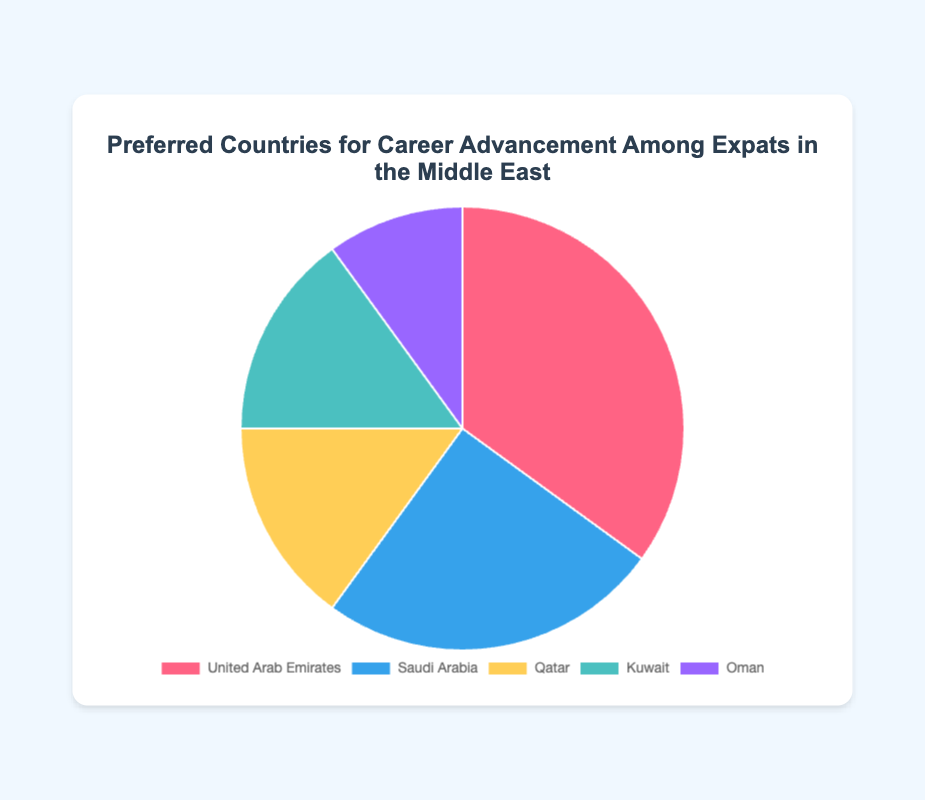Which country is chosen by the highest percentage of expats for career advancement? The United Arab Emirates has the highest percentage, as it's shown to lead with 35%.
Answer: United Arab Emirates What is the total percentage of expats who prefer Qatar and Kuwait combined? The percentages for Qatar and Kuwait are 15% and 15%, respectively. Adding these gives 15% + 15% = 30%.
Answer: 30% Which country has the least percentage of expats choosing it for career advancement? Oman has the lowest percentage at 10%, as compared to other countries on the pie chart.
Answer: Oman Is the percentage of expats preferring Saudi Arabia greater than those preferring Kuwait? Yes, Saudi Arabia has 25%, which is greater than Kuwait's 15%.
Answer: Yes How does the percentage of expats preferring Qatar compare to those preferring the United Arab Emirates? Qatar is chosen by 15% of expats, whereas the United Arab Emirates is chosen by 35%, which is significantly higher.
Answer: United Arab Emirates What is the difference between the highest and lowest percentages? The highest percentage is 35% (United Arab Emirates), and the lowest is 10% (Oman). The difference is 35% - 10% = 25%.
Answer: 25% Rank the countries from most preferred to least preferred for career advancement. The countries rank as follows from most preferred to least preferred: United Arab Emirates (35%), Saudi Arabia (25%), Qatar (15%), Kuwait (15%), Oman (10%).
Answer: United Arab Emirates, Saudi Arabia, Qatar, Kuwait, Oman What is the combined percentage of expats preferring either United Arab Emirates or Saudi Arabia? Adding the percentages of the United Arab Emirates (35%) and Saudi Arabia (25%) gives 35% + 25% = 60%.
Answer: 60% What fraction of the total percentage is represented by expats preferring the United Arab Emirates? The United Arab Emirates accounts for 35% of the total. In fraction form, this is 35/100, which simplifies to 7/20.
Answer: 7/20 